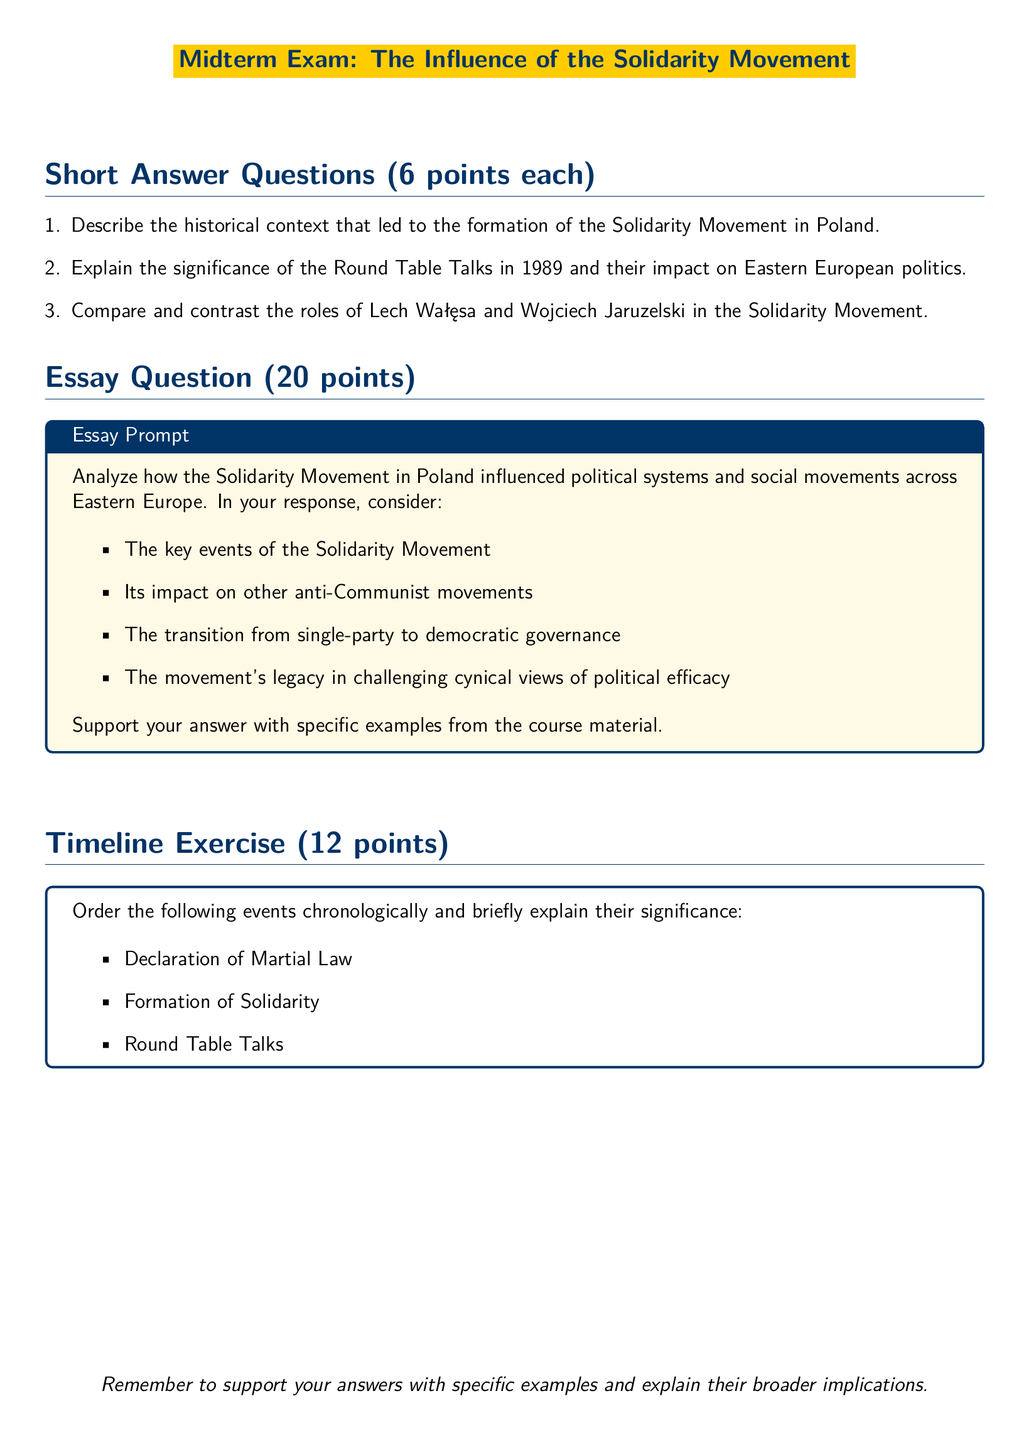What is the title of the exam? The title is prominently displayed at the top of the document within a color box.
Answer: Midterm Exam: The Influence of the Solidarity Movement How many points is the essay question worth? The points value for the essay question is stated within the tcolorbox.
Answer: 20 points What year did the Round Table Talks take place? The document references key events but does not explicitly state the year; however, the Round Table Talks generally refer to 1989.
Answer: 1989 Who were the two key figures mentioned in the comparison question? The question specifically identifies the individuals discussed in the short answer section.
Answer: Lech Wałęsa and Wojciech Jaruzelski What is the total number of short answer questions? The list of questions is clearly numbered in the document.
Answer: 3 What is the primary theme of the essay prompt? The essay prompt outlines a specific focus for analysis in the context of the Solidarity Movement.
Answer: Influence on political systems and social movements How many points is the timeline exercise worth? The document indicates the points assigned to the timeline exercise in the relevant section.
Answer: 12 points What are the three events listed in the timeline exercise? The events are part of the timeline exercise and are specifically mentioned.
Answer: Declaration of Martial Law, Formation of Solidarity, Round Table Talks What is the color of the main theme used in the document? The document describes specific color usage for sections and headings.
Answer: RGB(0,51,102) 